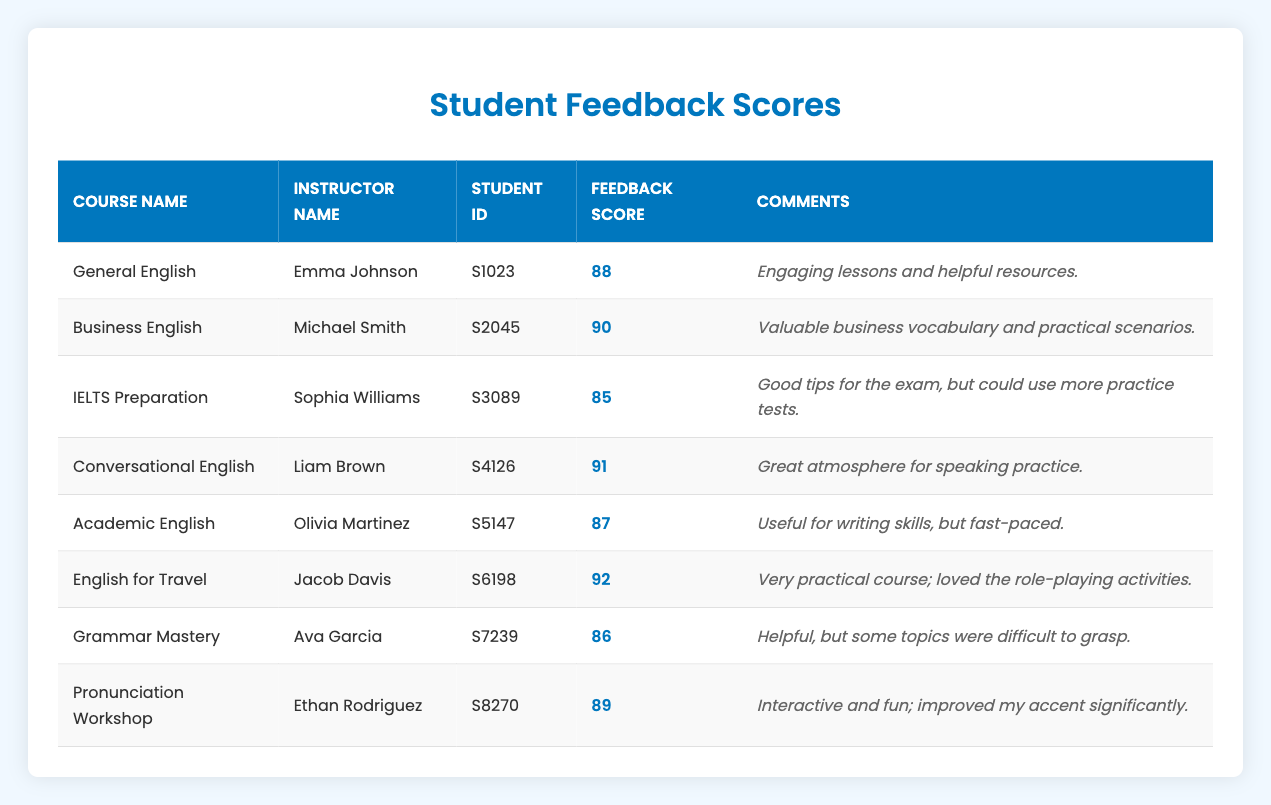What is the feedback score for the "Grammar Mastery" course? The table directly lists the score for "Grammar Mastery" under the Feedback Score column, which is 86.
Answer: 86 Who is the instructor for the "English for Travel" course? The instructor for "English for Travel" is listed in the Instructor Name column of the table, which shows that Jacob Davis teaches this course.
Answer: Jacob Davis What is the average feedback score across all courses? To find the average, we need to sum up all the feedback scores: 88 + 90 + 85 + 91 + 87 + 92 + 86 + 89 = 718. There are 8 courses, so we divide the total score by 8: 718 / 8 = 89.75.
Answer: 89.75 Did "Sophia Williams" receive a higher feedback score than "Ava Garcia"? Looking at the feedback scores, Sophia Williams received a score of 85 for the IELTS Preparation course, while Ava Garcia received a score of 86 for Grammar Mastery. Since 85 is not greater than 86, the answer is no.
Answer: No Which course had the highest feedback score and what was it? We need to compare the feedback scores across all courses. The highest score is found in the "English for Travel" course with a score of 92, which is the highest when compared to scores for all other courses.
Answer: English for Travel, 92 What percentage of courses received a feedback score of 90 or above? There are two courses with scores of 90 or above: Business English (90) and English for Travel (92). Since there are 8 courses in total, the percentage is calculated as (2/8) * 100 = 25%.
Answer: 25% Which instructor received the lowest average score when considering their individual ratings? To find the lowest average score, we look at the scores associated with each instructor. Emma Johnson (88), Michael Smith (90), Sophia Williams (85), Liam Brown (91), Olivia Martinez (87), Jacob Davis (92), Ava Garcia (86), Ethan Rodriguez (89). The instructor with the lowest score is Sophia Williams with 85.
Answer: Sophia Williams, 85 Were there any remarks indicating that the courses offered enough practice material? The comments for the IELTS Preparation course state: "Good tips for the exam, but could use more practice tests," indicating a lack of sufficient practice materials. Since it's the only course comment mentioning insufficient practice, the answer is yes.
Answer: Yes 